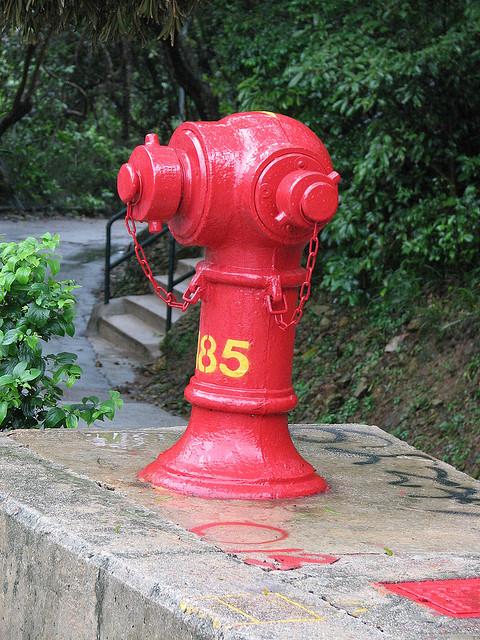Is water running out of the fire hydrant?
Be succinct. No. What are the numbers on the hydrant?
Keep it brief. 85. Is this in a city?
Give a very brief answer. Yes. What color is the fire hydrant?
Short answer required. Red. 